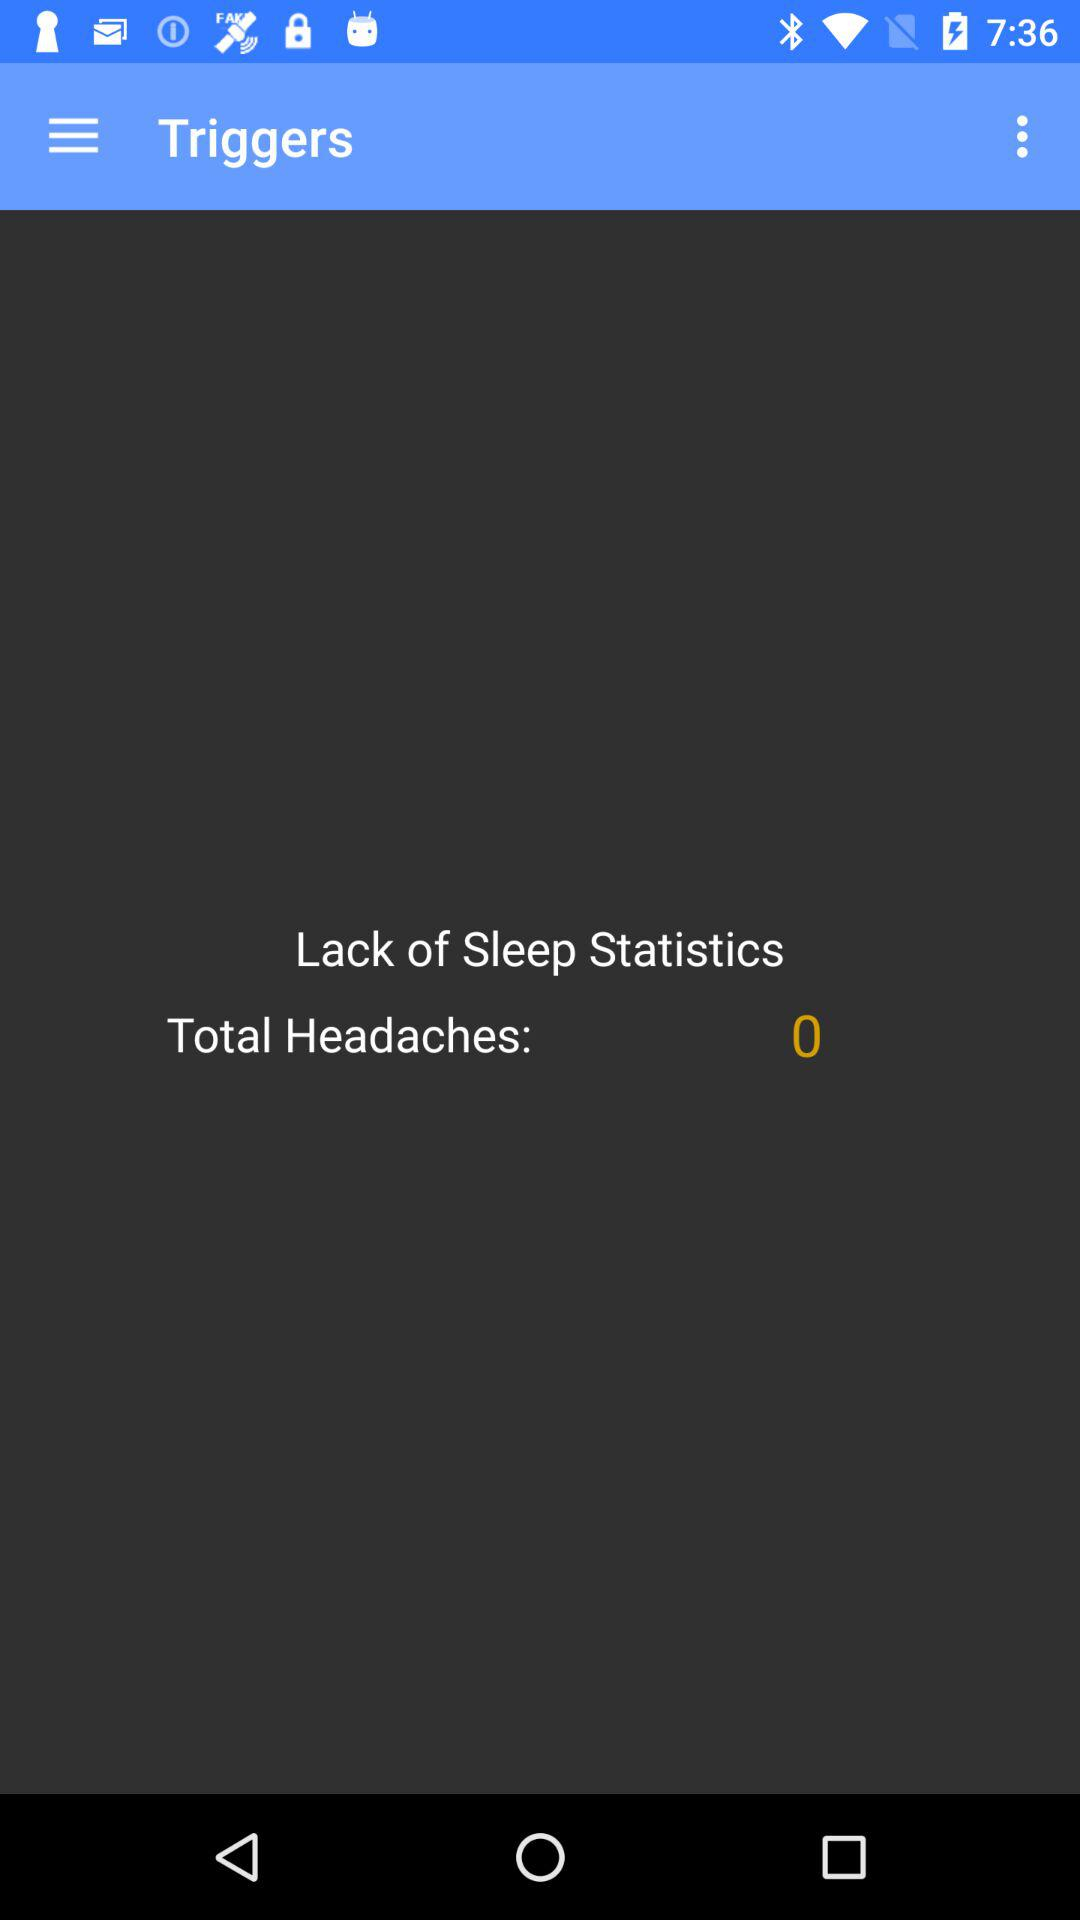What is the total number of headaches? The total number of headaches is 0. 